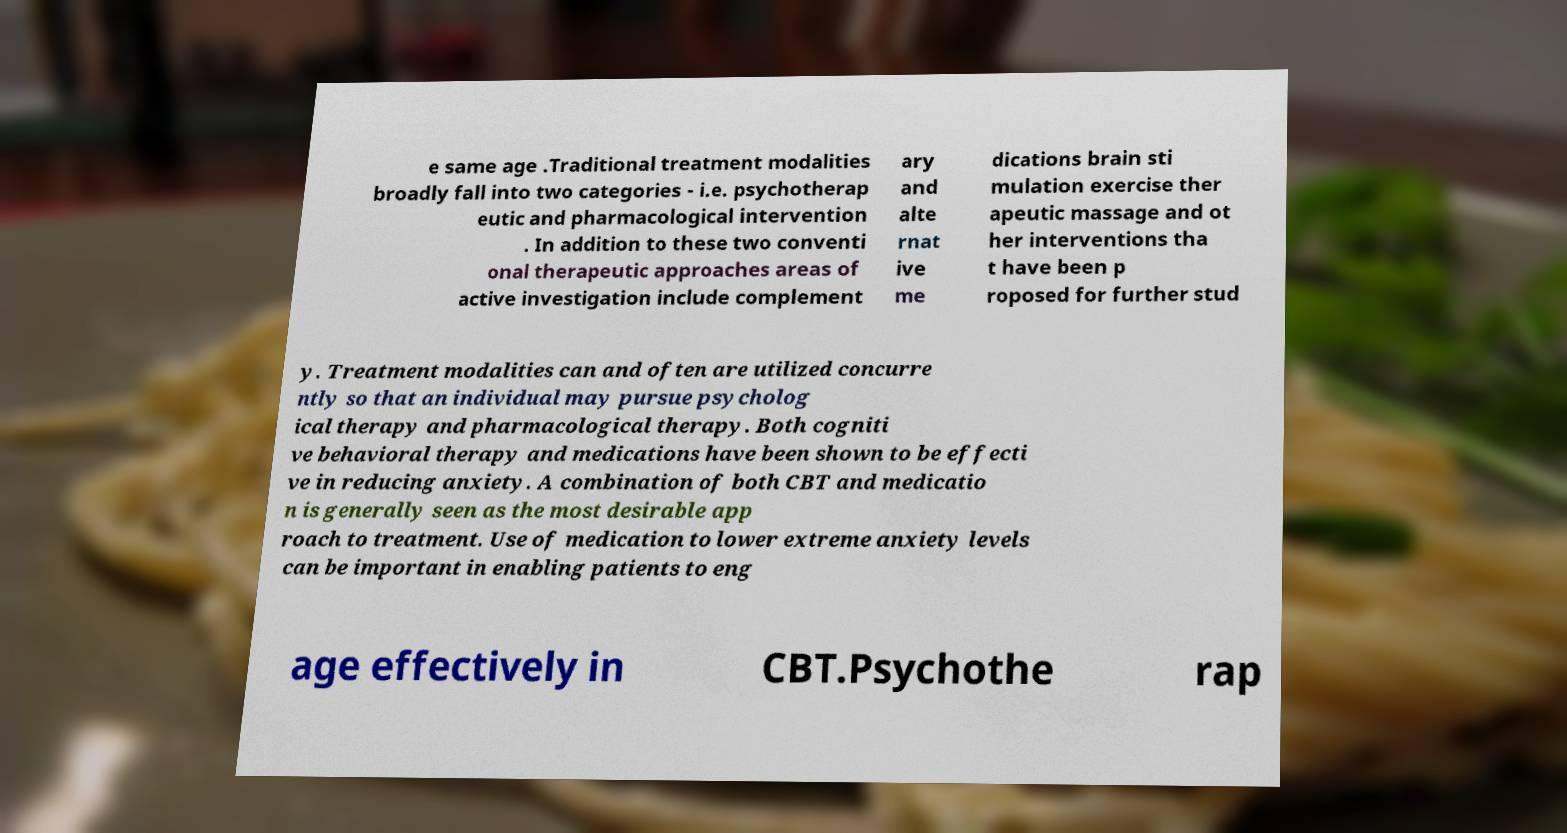Can you read and provide the text displayed in the image?This photo seems to have some interesting text. Can you extract and type it out for me? e same age .Traditional treatment modalities broadly fall into two categories - i.e. psychotherap eutic and pharmacological intervention . In addition to these two conventi onal therapeutic approaches areas of active investigation include complement ary and alte rnat ive me dications brain sti mulation exercise ther apeutic massage and ot her interventions tha t have been p roposed for further stud y. Treatment modalities can and often are utilized concurre ntly so that an individual may pursue psycholog ical therapy and pharmacological therapy. Both cogniti ve behavioral therapy and medications have been shown to be effecti ve in reducing anxiety. A combination of both CBT and medicatio n is generally seen as the most desirable app roach to treatment. Use of medication to lower extreme anxiety levels can be important in enabling patients to eng age effectively in CBT.Psychothe rap 